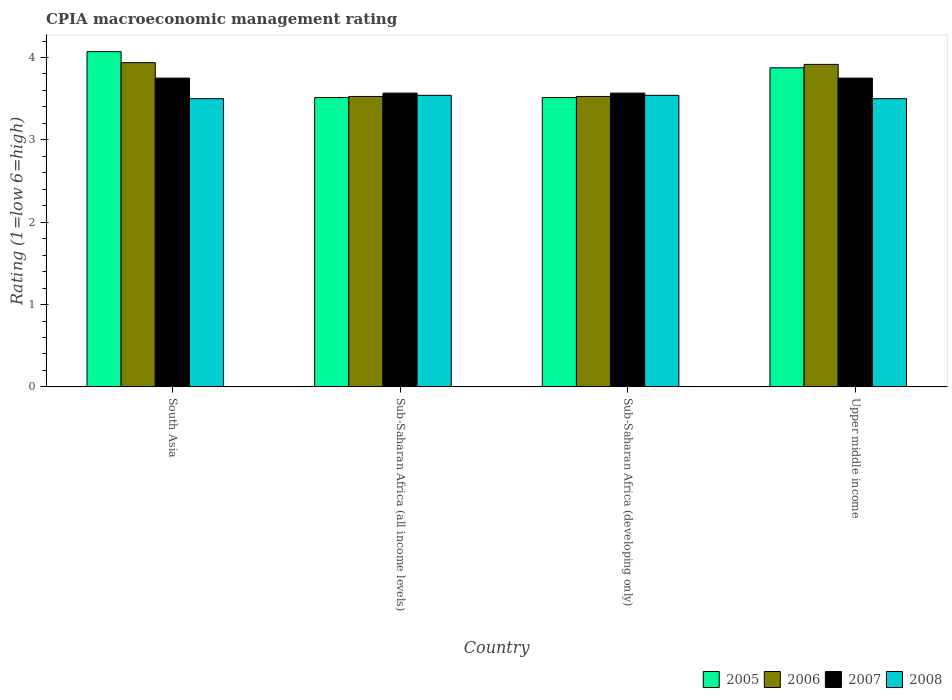How many bars are there on the 2nd tick from the right?
Ensure brevity in your answer.  4. What is the CPIA rating in 2007 in Sub-Saharan Africa (all income levels)?
Provide a succinct answer. 3.57. Across all countries, what is the maximum CPIA rating in 2008?
Provide a succinct answer. 3.54. Across all countries, what is the minimum CPIA rating in 2007?
Give a very brief answer. 3.57. In which country was the CPIA rating in 2008 minimum?
Make the answer very short. South Asia. What is the total CPIA rating in 2008 in the graph?
Provide a succinct answer. 14.08. What is the difference between the CPIA rating in 2006 in South Asia and that in Sub-Saharan Africa (all income levels)?
Make the answer very short. 0.41. What is the difference between the CPIA rating in 2005 in South Asia and the CPIA rating in 2006 in Sub-Saharan Africa (all income levels)?
Provide a short and direct response. 0.54. What is the average CPIA rating in 2005 per country?
Provide a succinct answer. 3.74. What is the difference between the CPIA rating of/in 2005 and CPIA rating of/in 2007 in Upper middle income?
Offer a very short reply. 0.12. In how many countries, is the CPIA rating in 2006 greater than 1.6?
Offer a very short reply. 4. What is the ratio of the CPIA rating in 2005 in South Asia to that in Upper middle income?
Your answer should be compact. 1.05. What is the difference between the highest and the second highest CPIA rating in 2007?
Your answer should be very brief. -0.18. What is the difference between the highest and the lowest CPIA rating in 2008?
Your response must be concise. 0.04. In how many countries, is the CPIA rating in 2005 greater than the average CPIA rating in 2005 taken over all countries?
Provide a short and direct response. 2. Is the sum of the CPIA rating in 2006 in South Asia and Upper middle income greater than the maximum CPIA rating in 2007 across all countries?
Offer a very short reply. Yes. What does the 1st bar from the left in Sub-Saharan Africa (developing only) represents?
Give a very brief answer. 2005. Is it the case that in every country, the sum of the CPIA rating in 2008 and CPIA rating in 2007 is greater than the CPIA rating in 2005?
Make the answer very short. Yes. How many bars are there?
Make the answer very short. 16. Are all the bars in the graph horizontal?
Offer a terse response. No. Are the values on the major ticks of Y-axis written in scientific E-notation?
Keep it short and to the point. No. Where does the legend appear in the graph?
Your response must be concise. Bottom right. What is the title of the graph?
Your answer should be compact. CPIA macroeconomic management rating. What is the label or title of the Y-axis?
Your response must be concise. Rating (1=low 6=high). What is the Rating (1=low 6=high) in 2005 in South Asia?
Provide a short and direct response. 4.07. What is the Rating (1=low 6=high) of 2006 in South Asia?
Your response must be concise. 3.94. What is the Rating (1=low 6=high) in 2007 in South Asia?
Your answer should be very brief. 3.75. What is the Rating (1=low 6=high) in 2008 in South Asia?
Offer a very short reply. 3.5. What is the Rating (1=low 6=high) of 2005 in Sub-Saharan Africa (all income levels)?
Offer a terse response. 3.51. What is the Rating (1=low 6=high) in 2006 in Sub-Saharan Africa (all income levels)?
Your answer should be compact. 3.53. What is the Rating (1=low 6=high) in 2007 in Sub-Saharan Africa (all income levels)?
Provide a succinct answer. 3.57. What is the Rating (1=low 6=high) in 2008 in Sub-Saharan Africa (all income levels)?
Your answer should be compact. 3.54. What is the Rating (1=low 6=high) in 2005 in Sub-Saharan Africa (developing only)?
Give a very brief answer. 3.51. What is the Rating (1=low 6=high) of 2006 in Sub-Saharan Africa (developing only)?
Your response must be concise. 3.53. What is the Rating (1=low 6=high) of 2007 in Sub-Saharan Africa (developing only)?
Your answer should be very brief. 3.57. What is the Rating (1=low 6=high) of 2008 in Sub-Saharan Africa (developing only)?
Give a very brief answer. 3.54. What is the Rating (1=low 6=high) of 2005 in Upper middle income?
Your answer should be compact. 3.88. What is the Rating (1=low 6=high) in 2006 in Upper middle income?
Provide a succinct answer. 3.92. What is the Rating (1=low 6=high) in 2007 in Upper middle income?
Offer a very short reply. 3.75. Across all countries, what is the maximum Rating (1=low 6=high) of 2005?
Your answer should be compact. 4.07. Across all countries, what is the maximum Rating (1=low 6=high) of 2006?
Provide a succinct answer. 3.94. Across all countries, what is the maximum Rating (1=low 6=high) of 2007?
Offer a terse response. 3.75. Across all countries, what is the maximum Rating (1=low 6=high) in 2008?
Your answer should be very brief. 3.54. Across all countries, what is the minimum Rating (1=low 6=high) of 2005?
Offer a terse response. 3.51. Across all countries, what is the minimum Rating (1=low 6=high) of 2006?
Ensure brevity in your answer.  3.53. Across all countries, what is the minimum Rating (1=low 6=high) in 2007?
Offer a terse response. 3.57. Across all countries, what is the minimum Rating (1=low 6=high) of 2008?
Your answer should be very brief. 3.5. What is the total Rating (1=low 6=high) in 2005 in the graph?
Your answer should be very brief. 14.97. What is the total Rating (1=low 6=high) in 2006 in the graph?
Keep it short and to the point. 14.91. What is the total Rating (1=low 6=high) in 2007 in the graph?
Give a very brief answer. 14.64. What is the total Rating (1=low 6=high) in 2008 in the graph?
Your response must be concise. 14.08. What is the difference between the Rating (1=low 6=high) in 2005 in South Asia and that in Sub-Saharan Africa (all income levels)?
Make the answer very short. 0.56. What is the difference between the Rating (1=low 6=high) in 2006 in South Asia and that in Sub-Saharan Africa (all income levels)?
Offer a terse response. 0.41. What is the difference between the Rating (1=low 6=high) in 2007 in South Asia and that in Sub-Saharan Africa (all income levels)?
Your answer should be compact. 0.18. What is the difference between the Rating (1=low 6=high) in 2008 in South Asia and that in Sub-Saharan Africa (all income levels)?
Your response must be concise. -0.04. What is the difference between the Rating (1=low 6=high) in 2005 in South Asia and that in Sub-Saharan Africa (developing only)?
Make the answer very short. 0.56. What is the difference between the Rating (1=low 6=high) in 2006 in South Asia and that in Sub-Saharan Africa (developing only)?
Your answer should be very brief. 0.41. What is the difference between the Rating (1=low 6=high) of 2007 in South Asia and that in Sub-Saharan Africa (developing only)?
Give a very brief answer. 0.18. What is the difference between the Rating (1=low 6=high) of 2008 in South Asia and that in Sub-Saharan Africa (developing only)?
Provide a succinct answer. -0.04. What is the difference between the Rating (1=low 6=high) of 2005 in South Asia and that in Upper middle income?
Your answer should be very brief. 0.2. What is the difference between the Rating (1=low 6=high) of 2006 in South Asia and that in Upper middle income?
Provide a succinct answer. 0.02. What is the difference between the Rating (1=low 6=high) in 2007 in South Asia and that in Upper middle income?
Provide a succinct answer. 0. What is the difference between the Rating (1=low 6=high) of 2005 in Sub-Saharan Africa (all income levels) and that in Sub-Saharan Africa (developing only)?
Provide a succinct answer. 0. What is the difference between the Rating (1=low 6=high) of 2008 in Sub-Saharan Africa (all income levels) and that in Sub-Saharan Africa (developing only)?
Keep it short and to the point. 0. What is the difference between the Rating (1=low 6=high) of 2005 in Sub-Saharan Africa (all income levels) and that in Upper middle income?
Offer a very short reply. -0.36. What is the difference between the Rating (1=low 6=high) of 2006 in Sub-Saharan Africa (all income levels) and that in Upper middle income?
Your answer should be very brief. -0.39. What is the difference between the Rating (1=low 6=high) of 2007 in Sub-Saharan Africa (all income levels) and that in Upper middle income?
Offer a terse response. -0.18. What is the difference between the Rating (1=low 6=high) in 2008 in Sub-Saharan Africa (all income levels) and that in Upper middle income?
Your response must be concise. 0.04. What is the difference between the Rating (1=low 6=high) of 2005 in Sub-Saharan Africa (developing only) and that in Upper middle income?
Your answer should be compact. -0.36. What is the difference between the Rating (1=low 6=high) in 2006 in Sub-Saharan Africa (developing only) and that in Upper middle income?
Ensure brevity in your answer.  -0.39. What is the difference between the Rating (1=low 6=high) in 2007 in Sub-Saharan Africa (developing only) and that in Upper middle income?
Keep it short and to the point. -0.18. What is the difference between the Rating (1=low 6=high) in 2008 in Sub-Saharan Africa (developing only) and that in Upper middle income?
Make the answer very short. 0.04. What is the difference between the Rating (1=low 6=high) in 2005 in South Asia and the Rating (1=low 6=high) in 2006 in Sub-Saharan Africa (all income levels)?
Give a very brief answer. 0.54. What is the difference between the Rating (1=low 6=high) of 2005 in South Asia and the Rating (1=low 6=high) of 2007 in Sub-Saharan Africa (all income levels)?
Offer a very short reply. 0.5. What is the difference between the Rating (1=low 6=high) of 2005 in South Asia and the Rating (1=low 6=high) of 2008 in Sub-Saharan Africa (all income levels)?
Your answer should be very brief. 0.53. What is the difference between the Rating (1=low 6=high) of 2006 in South Asia and the Rating (1=low 6=high) of 2007 in Sub-Saharan Africa (all income levels)?
Give a very brief answer. 0.37. What is the difference between the Rating (1=low 6=high) in 2006 in South Asia and the Rating (1=low 6=high) in 2008 in Sub-Saharan Africa (all income levels)?
Provide a short and direct response. 0.4. What is the difference between the Rating (1=low 6=high) in 2007 in South Asia and the Rating (1=low 6=high) in 2008 in Sub-Saharan Africa (all income levels)?
Give a very brief answer. 0.21. What is the difference between the Rating (1=low 6=high) in 2005 in South Asia and the Rating (1=low 6=high) in 2006 in Sub-Saharan Africa (developing only)?
Your response must be concise. 0.54. What is the difference between the Rating (1=low 6=high) of 2005 in South Asia and the Rating (1=low 6=high) of 2007 in Sub-Saharan Africa (developing only)?
Keep it short and to the point. 0.5. What is the difference between the Rating (1=low 6=high) of 2005 in South Asia and the Rating (1=low 6=high) of 2008 in Sub-Saharan Africa (developing only)?
Offer a very short reply. 0.53. What is the difference between the Rating (1=low 6=high) in 2006 in South Asia and the Rating (1=low 6=high) in 2007 in Sub-Saharan Africa (developing only)?
Provide a short and direct response. 0.37. What is the difference between the Rating (1=low 6=high) in 2006 in South Asia and the Rating (1=low 6=high) in 2008 in Sub-Saharan Africa (developing only)?
Provide a succinct answer. 0.4. What is the difference between the Rating (1=low 6=high) of 2007 in South Asia and the Rating (1=low 6=high) of 2008 in Sub-Saharan Africa (developing only)?
Give a very brief answer. 0.21. What is the difference between the Rating (1=low 6=high) in 2005 in South Asia and the Rating (1=low 6=high) in 2006 in Upper middle income?
Ensure brevity in your answer.  0.15. What is the difference between the Rating (1=low 6=high) of 2005 in South Asia and the Rating (1=low 6=high) of 2007 in Upper middle income?
Provide a succinct answer. 0.32. What is the difference between the Rating (1=low 6=high) of 2005 in South Asia and the Rating (1=low 6=high) of 2008 in Upper middle income?
Give a very brief answer. 0.57. What is the difference between the Rating (1=low 6=high) of 2006 in South Asia and the Rating (1=low 6=high) of 2007 in Upper middle income?
Offer a very short reply. 0.19. What is the difference between the Rating (1=low 6=high) in 2006 in South Asia and the Rating (1=low 6=high) in 2008 in Upper middle income?
Your answer should be very brief. 0.44. What is the difference between the Rating (1=low 6=high) in 2005 in Sub-Saharan Africa (all income levels) and the Rating (1=low 6=high) in 2006 in Sub-Saharan Africa (developing only)?
Offer a terse response. -0.01. What is the difference between the Rating (1=low 6=high) of 2005 in Sub-Saharan Africa (all income levels) and the Rating (1=low 6=high) of 2007 in Sub-Saharan Africa (developing only)?
Your answer should be very brief. -0.05. What is the difference between the Rating (1=low 6=high) in 2005 in Sub-Saharan Africa (all income levels) and the Rating (1=low 6=high) in 2008 in Sub-Saharan Africa (developing only)?
Make the answer very short. -0.03. What is the difference between the Rating (1=low 6=high) of 2006 in Sub-Saharan Africa (all income levels) and the Rating (1=low 6=high) of 2007 in Sub-Saharan Africa (developing only)?
Provide a short and direct response. -0.04. What is the difference between the Rating (1=low 6=high) in 2006 in Sub-Saharan Africa (all income levels) and the Rating (1=low 6=high) in 2008 in Sub-Saharan Africa (developing only)?
Provide a succinct answer. -0.01. What is the difference between the Rating (1=low 6=high) in 2007 in Sub-Saharan Africa (all income levels) and the Rating (1=low 6=high) in 2008 in Sub-Saharan Africa (developing only)?
Your answer should be compact. 0.03. What is the difference between the Rating (1=low 6=high) in 2005 in Sub-Saharan Africa (all income levels) and the Rating (1=low 6=high) in 2006 in Upper middle income?
Your answer should be compact. -0.4. What is the difference between the Rating (1=low 6=high) in 2005 in Sub-Saharan Africa (all income levels) and the Rating (1=low 6=high) in 2007 in Upper middle income?
Your answer should be compact. -0.24. What is the difference between the Rating (1=low 6=high) of 2005 in Sub-Saharan Africa (all income levels) and the Rating (1=low 6=high) of 2008 in Upper middle income?
Your response must be concise. 0.01. What is the difference between the Rating (1=low 6=high) in 2006 in Sub-Saharan Africa (all income levels) and the Rating (1=low 6=high) in 2007 in Upper middle income?
Your answer should be compact. -0.22. What is the difference between the Rating (1=low 6=high) of 2006 in Sub-Saharan Africa (all income levels) and the Rating (1=low 6=high) of 2008 in Upper middle income?
Provide a succinct answer. 0.03. What is the difference between the Rating (1=low 6=high) of 2007 in Sub-Saharan Africa (all income levels) and the Rating (1=low 6=high) of 2008 in Upper middle income?
Offer a terse response. 0.07. What is the difference between the Rating (1=low 6=high) of 2005 in Sub-Saharan Africa (developing only) and the Rating (1=low 6=high) of 2006 in Upper middle income?
Ensure brevity in your answer.  -0.4. What is the difference between the Rating (1=low 6=high) of 2005 in Sub-Saharan Africa (developing only) and the Rating (1=low 6=high) of 2007 in Upper middle income?
Provide a succinct answer. -0.24. What is the difference between the Rating (1=low 6=high) in 2005 in Sub-Saharan Africa (developing only) and the Rating (1=low 6=high) in 2008 in Upper middle income?
Your response must be concise. 0.01. What is the difference between the Rating (1=low 6=high) in 2006 in Sub-Saharan Africa (developing only) and the Rating (1=low 6=high) in 2007 in Upper middle income?
Provide a succinct answer. -0.22. What is the difference between the Rating (1=low 6=high) of 2006 in Sub-Saharan Africa (developing only) and the Rating (1=low 6=high) of 2008 in Upper middle income?
Your response must be concise. 0.03. What is the difference between the Rating (1=low 6=high) in 2007 in Sub-Saharan Africa (developing only) and the Rating (1=low 6=high) in 2008 in Upper middle income?
Make the answer very short. 0.07. What is the average Rating (1=low 6=high) of 2005 per country?
Give a very brief answer. 3.74. What is the average Rating (1=low 6=high) of 2006 per country?
Give a very brief answer. 3.73. What is the average Rating (1=low 6=high) of 2007 per country?
Your response must be concise. 3.66. What is the average Rating (1=low 6=high) in 2008 per country?
Keep it short and to the point. 3.52. What is the difference between the Rating (1=low 6=high) of 2005 and Rating (1=low 6=high) of 2006 in South Asia?
Your answer should be very brief. 0.13. What is the difference between the Rating (1=low 6=high) of 2005 and Rating (1=low 6=high) of 2007 in South Asia?
Make the answer very short. 0.32. What is the difference between the Rating (1=low 6=high) of 2005 and Rating (1=low 6=high) of 2008 in South Asia?
Your answer should be compact. 0.57. What is the difference between the Rating (1=low 6=high) of 2006 and Rating (1=low 6=high) of 2007 in South Asia?
Ensure brevity in your answer.  0.19. What is the difference between the Rating (1=low 6=high) of 2006 and Rating (1=low 6=high) of 2008 in South Asia?
Your answer should be compact. 0.44. What is the difference between the Rating (1=low 6=high) of 2007 and Rating (1=low 6=high) of 2008 in South Asia?
Give a very brief answer. 0.25. What is the difference between the Rating (1=low 6=high) of 2005 and Rating (1=low 6=high) of 2006 in Sub-Saharan Africa (all income levels)?
Your answer should be compact. -0.01. What is the difference between the Rating (1=low 6=high) in 2005 and Rating (1=low 6=high) in 2007 in Sub-Saharan Africa (all income levels)?
Provide a succinct answer. -0.05. What is the difference between the Rating (1=low 6=high) of 2005 and Rating (1=low 6=high) of 2008 in Sub-Saharan Africa (all income levels)?
Your response must be concise. -0.03. What is the difference between the Rating (1=low 6=high) of 2006 and Rating (1=low 6=high) of 2007 in Sub-Saharan Africa (all income levels)?
Your answer should be very brief. -0.04. What is the difference between the Rating (1=low 6=high) of 2006 and Rating (1=low 6=high) of 2008 in Sub-Saharan Africa (all income levels)?
Offer a terse response. -0.01. What is the difference between the Rating (1=low 6=high) in 2007 and Rating (1=low 6=high) in 2008 in Sub-Saharan Africa (all income levels)?
Keep it short and to the point. 0.03. What is the difference between the Rating (1=low 6=high) in 2005 and Rating (1=low 6=high) in 2006 in Sub-Saharan Africa (developing only)?
Give a very brief answer. -0.01. What is the difference between the Rating (1=low 6=high) of 2005 and Rating (1=low 6=high) of 2007 in Sub-Saharan Africa (developing only)?
Give a very brief answer. -0.05. What is the difference between the Rating (1=low 6=high) in 2005 and Rating (1=low 6=high) in 2008 in Sub-Saharan Africa (developing only)?
Provide a short and direct response. -0.03. What is the difference between the Rating (1=low 6=high) in 2006 and Rating (1=low 6=high) in 2007 in Sub-Saharan Africa (developing only)?
Your response must be concise. -0.04. What is the difference between the Rating (1=low 6=high) of 2006 and Rating (1=low 6=high) of 2008 in Sub-Saharan Africa (developing only)?
Offer a very short reply. -0.01. What is the difference between the Rating (1=low 6=high) in 2007 and Rating (1=low 6=high) in 2008 in Sub-Saharan Africa (developing only)?
Offer a very short reply. 0.03. What is the difference between the Rating (1=low 6=high) in 2005 and Rating (1=low 6=high) in 2006 in Upper middle income?
Give a very brief answer. -0.04. What is the difference between the Rating (1=low 6=high) in 2006 and Rating (1=low 6=high) in 2007 in Upper middle income?
Keep it short and to the point. 0.17. What is the difference between the Rating (1=low 6=high) in 2006 and Rating (1=low 6=high) in 2008 in Upper middle income?
Offer a terse response. 0.42. What is the ratio of the Rating (1=low 6=high) in 2005 in South Asia to that in Sub-Saharan Africa (all income levels)?
Provide a succinct answer. 1.16. What is the ratio of the Rating (1=low 6=high) of 2006 in South Asia to that in Sub-Saharan Africa (all income levels)?
Your response must be concise. 1.12. What is the ratio of the Rating (1=low 6=high) in 2007 in South Asia to that in Sub-Saharan Africa (all income levels)?
Offer a very short reply. 1.05. What is the ratio of the Rating (1=low 6=high) in 2005 in South Asia to that in Sub-Saharan Africa (developing only)?
Make the answer very short. 1.16. What is the ratio of the Rating (1=low 6=high) of 2006 in South Asia to that in Sub-Saharan Africa (developing only)?
Keep it short and to the point. 1.12. What is the ratio of the Rating (1=low 6=high) in 2007 in South Asia to that in Sub-Saharan Africa (developing only)?
Provide a short and direct response. 1.05. What is the ratio of the Rating (1=low 6=high) of 2005 in South Asia to that in Upper middle income?
Make the answer very short. 1.05. What is the ratio of the Rating (1=low 6=high) of 2008 in South Asia to that in Upper middle income?
Ensure brevity in your answer.  1. What is the ratio of the Rating (1=low 6=high) of 2005 in Sub-Saharan Africa (all income levels) to that in Sub-Saharan Africa (developing only)?
Ensure brevity in your answer.  1. What is the ratio of the Rating (1=low 6=high) in 2006 in Sub-Saharan Africa (all income levels) to that in Sub-Saharan Africa (developing only)?
Provide a succinct answer. 1. What is the ratio of the Rating (1=low 6=high) of 2007 in Sub-Saharan Africa (all income levels) to that in Sub-Saharan Africa (developing only)?
Your answer should be very brief. 1. What is the ratio of the Rating (1=low 6=high) in 2008 in Sub-Saharan Africa (all income levels) to that in Sub-Saharan Africa (developing only)?
Ensure brevity in your answer.  1. What is the ratio of the Rating (1=low 6=high) of 2005 in Sub-Saharan Africa (all income levels) to that in Upper middle income?
Offer a terse response. 0.91. What is the ratio of the Rating (1=low 6=high) of 2006 in Sub-Saharan Africa (all income levels) to that in Upper middle income?
Give a very brief answer. 0.9. What is the ratio of the Rating (1=low 6=high) of 2007 in Sub-Saharan Africa (all income levels) to that in Upper middle income?
Your answer should be very brief. 0.95. What is the ratio of the Rating (1=low 6=high) in 2008 in Sub-Saharan Africa (all income levels) to that in Upper middle income?
Provide a short and direct response. 1.01. What is the ratio of the Rating (1=low 6=high) in 2005 in Sub-Saharan Africa (developing only) to that in Upper middle income?
Provide a succinct answer. 0.91. What is the ratio of the Rating (1=low 6=high) of 2006 in Sub-Saharan Africa (developing only) to that in Upper middle income?
Keep it short and to the point. 0.9. What is the ratio of the Rating (1=low 6=high) of 2007 in Sub-Saharan Africa (developing only) to that in Upper middle income?
Your answer should be compact. 0.95. What is the ratio of the Rating (1=low 6=high) of 2008 in Sub-Saharan Africa (developing only) to that in Upper middle income?
Ensure brevity in your answer.  1.01. What is the difference between the highest and the second highest Rating (1=low 6=high) in 2005?
Provide a succinct answer. 0.2. What is the difference between the highest and the second highest Rating (1=low 6=high) of 2006?
Provide a short and direct response. 0.02. What is the difference between the highest and the lowest Rating (1=low 6=high) in 2005?
Ensure brevity in your answer.  0.56. What is the difference between the highest and the lowest Rating (1=low 6=high) in 2006?
Provide a succinct answer. 0.41. What is the difference between the highest and the lowest Rating (1=low 6=high) of 2007?
Your response must be concise. 0.18. What is the difference between the highest and the lowest Rating (1=low 6=high) in 2008?
Offer a terse response. 0.04. 